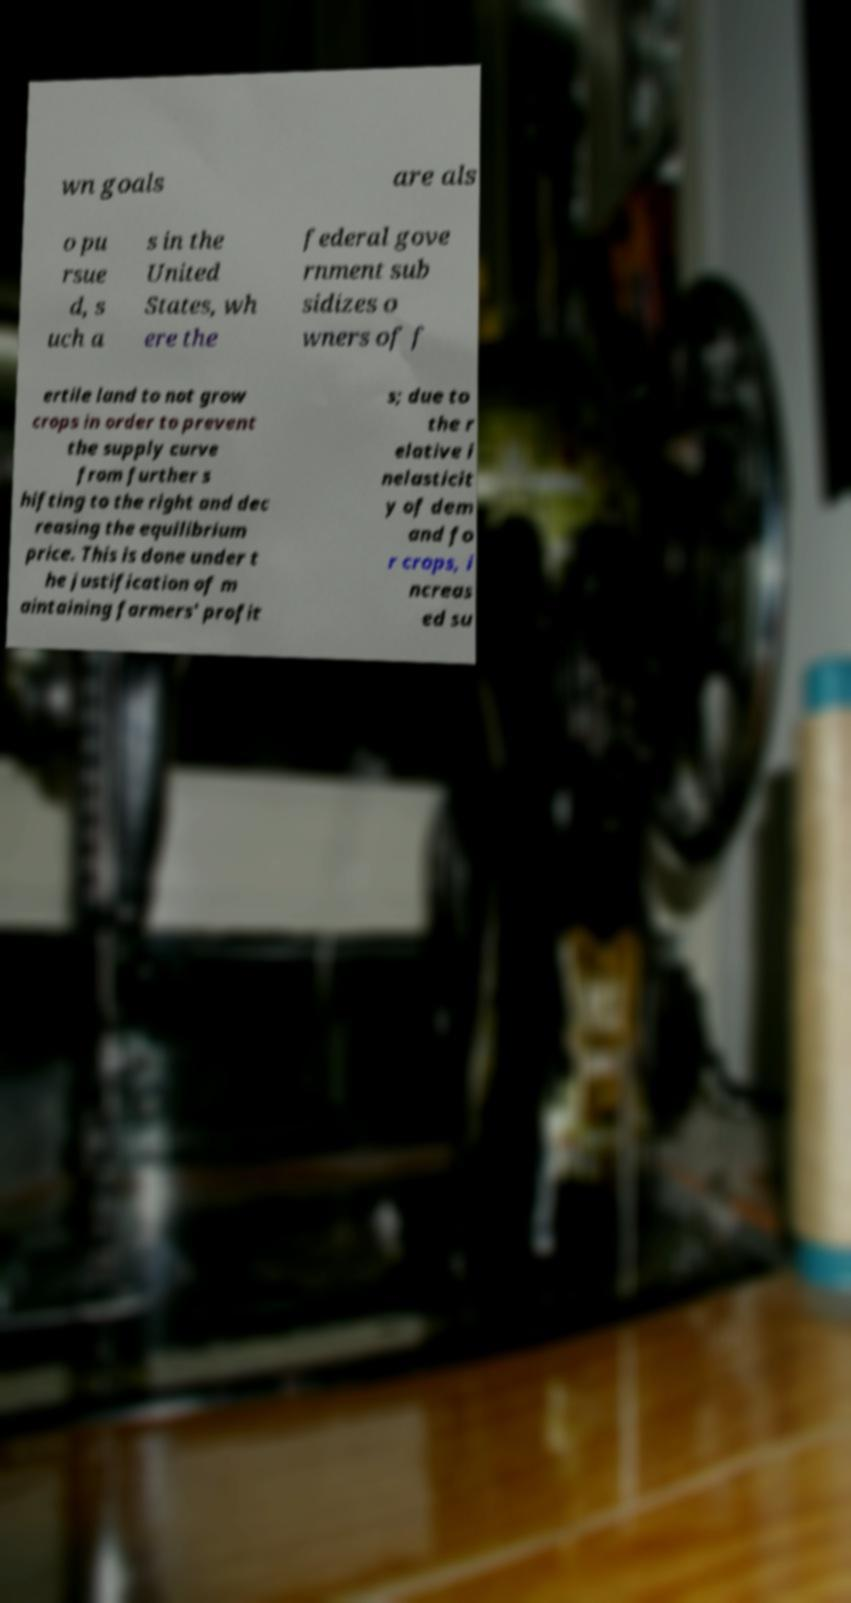What messages or text are displayed in this image? I need them in a readable, typed format. wn goals are als o pu rsue d, s uch a s in the United States, wh ere the federal gove rnment sub sidizes o wners of f ertile land to not grow crops in order to prevent the supply curve from further s hifting to the right and dec reasing the equilibrium price. This is done under t he justification of m aintaining farmers' profit s; due to the r elative i nelasticit y of dem and fo r crops, i ncreas ed su 